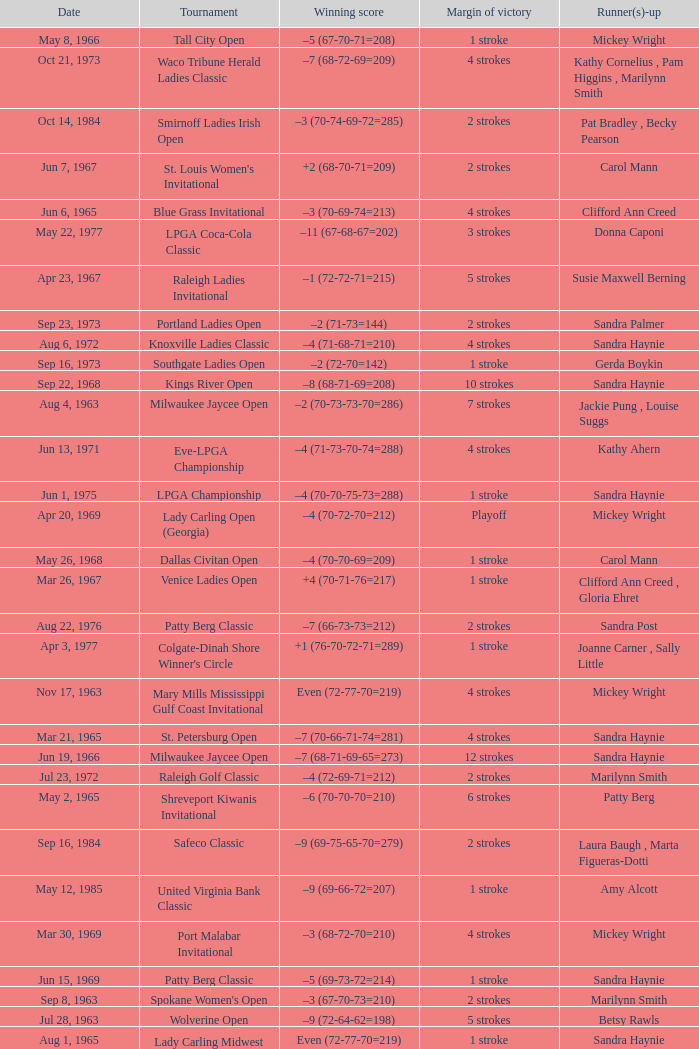What was the margin of victory on Apr 23, 1967? 5 strokes. 